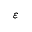Convert formula to latex. <formula><loc_0><loc_0><loc_500><loc_500>\varepsilon</formula> 